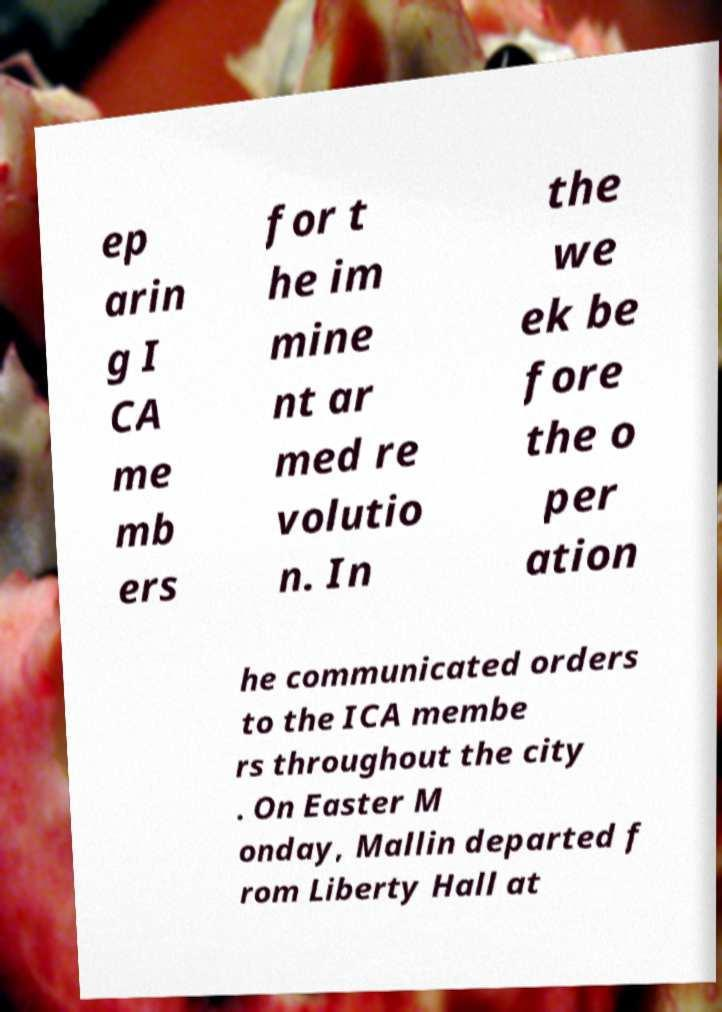Can you accurately transcribe the text from the provided image for me? ep arin g I CA me mb ers for t he im mine nt ar med re volutio n. In the we ek be fore the o per ation he communicated orders to the ICA membe rs throughout the city . On Easter M onday, Mallin departed f rom Liberty Hall at 